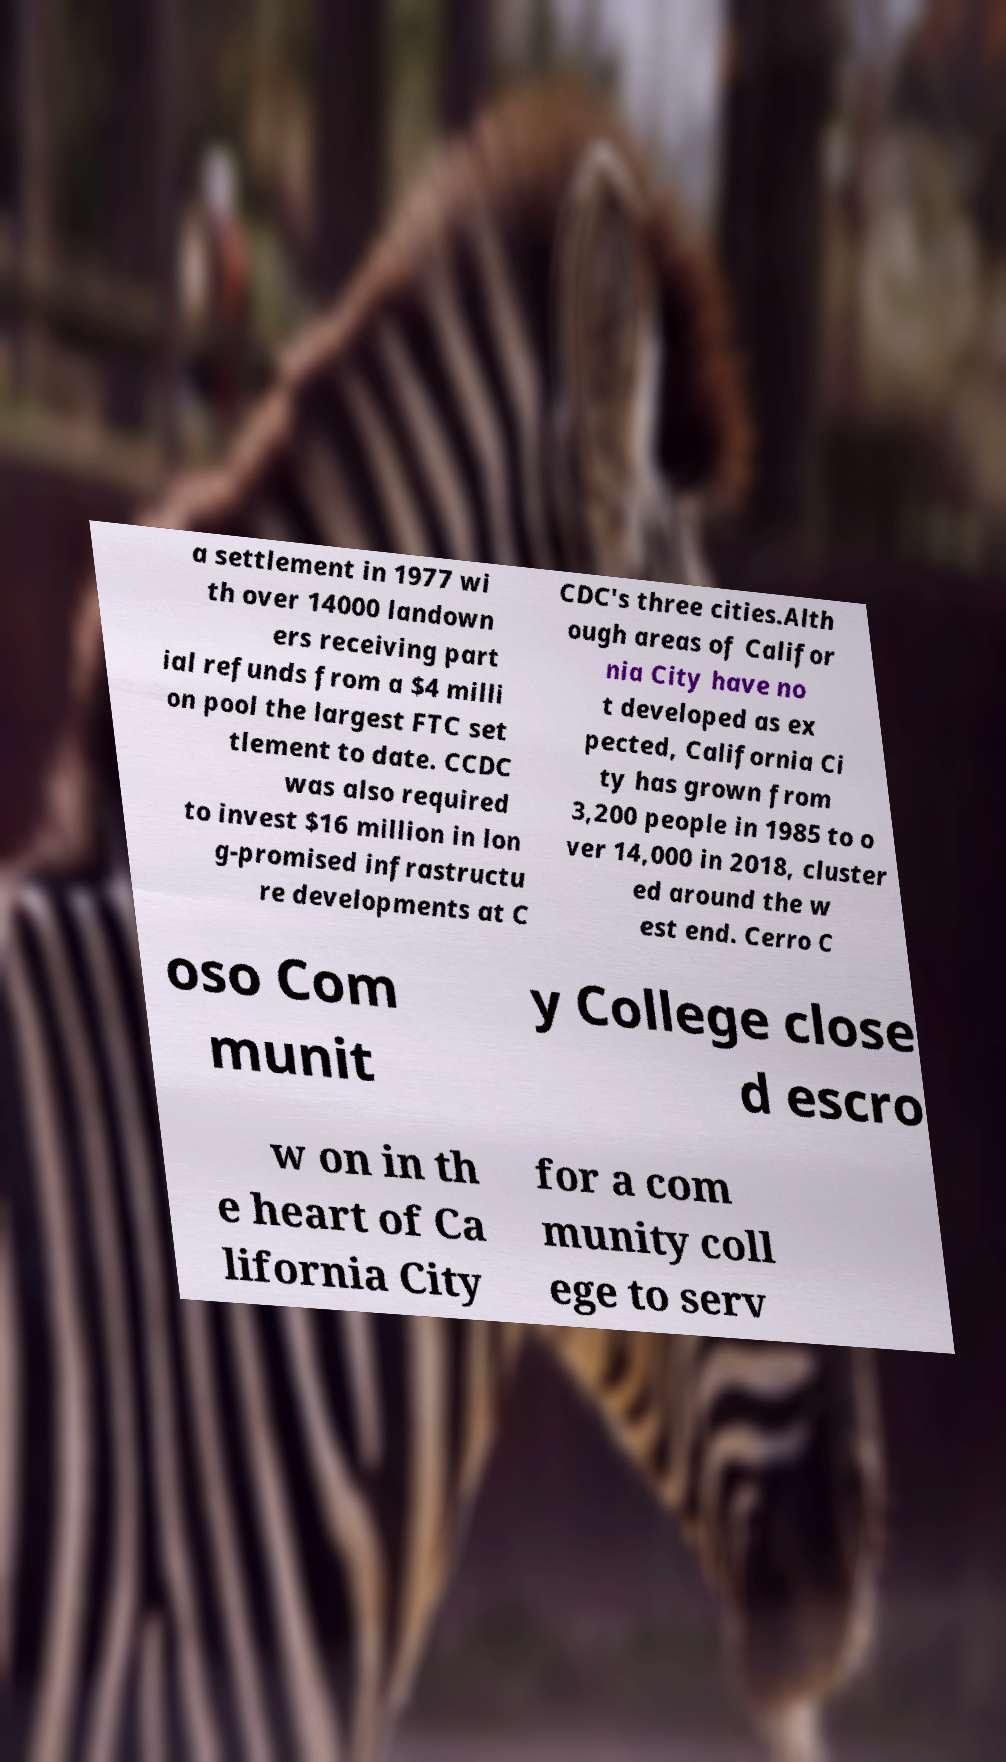Please identify and transcribe the text found in this image. a settlement in 1977 wi th over 14000 landown ers receiving part ial refunds from a $4 milli on pool the largest FTC set tlement to date. CCDC was also required to invest $16 million in lon g-promised infrastructu re developments at C CDC's three cities.Alth ough areas of Califor nia City have no t developed as ex pected, California Ci ty has grown from 3,200 people in 1985 to o ver 14,000 in 2018, cluster ed around the w est end. Cerro C oso Com munit y College close d escro w on in th e heart of Ca lifornia City for a com munity coll ege to serv 